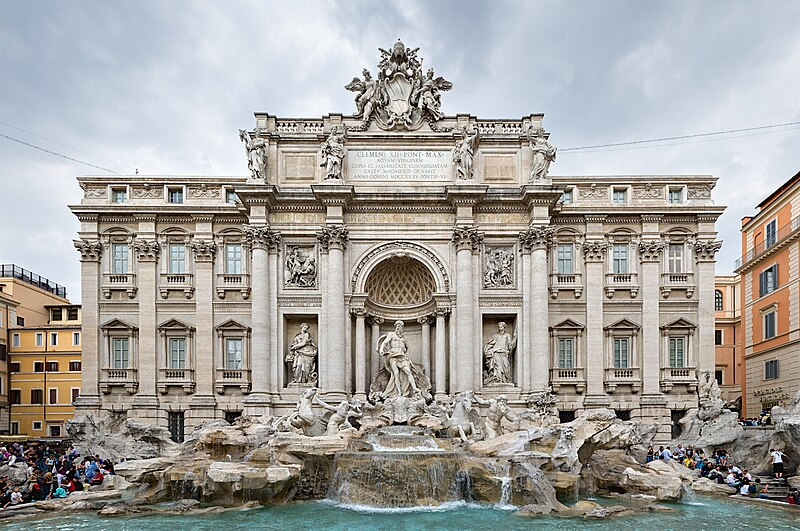Describe what you see in the image. The image depicts the Trevi Fountain in Rome, Italy. This famous Baroque fountain features a grand façade with elaborate sculptures, including the central figure of Oceanus (God of the sea), standing in a niche. He is flanked by Tritons and horses that represent the different moods of the sea. The marble sculptures are set against an impressive architectural backdrop. The clear blue water flows from the fountain into a large basin where numerous tourists are gathered around, admiring and taking photos. The surrounding buildings, painted in warm Italian colors, add charm and character to the scene. Why is the Trevi Fountain so popular among tourists? The Trevi Fountain is renowned worldwide for its stunning beauty and artistic value. Designed by Italian architect Nicola Salvi and completed by Giuseppe Pannini, it is a quintessential example of Baroque art and architecture. Tourists flock here not only to admire the intricate sculptures and the grandiosity of the fountain but also to partake in a tradition of throwing coins into the fountain. According to legend, throwing a coin into the Trevi Fountain ensures a return trip to Rome. This tradition, along with its appearances in various films like 'La Dolce Vita,' has cemented its status as a must-visit landmark. The fountain symbolizes not just Rome's artistic heritage but also its romantic allure, making it a favorite among visitors. 